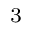<formula> <loc_0><loc_0><loc_500><loc_500>^ { 3 }</formula> 